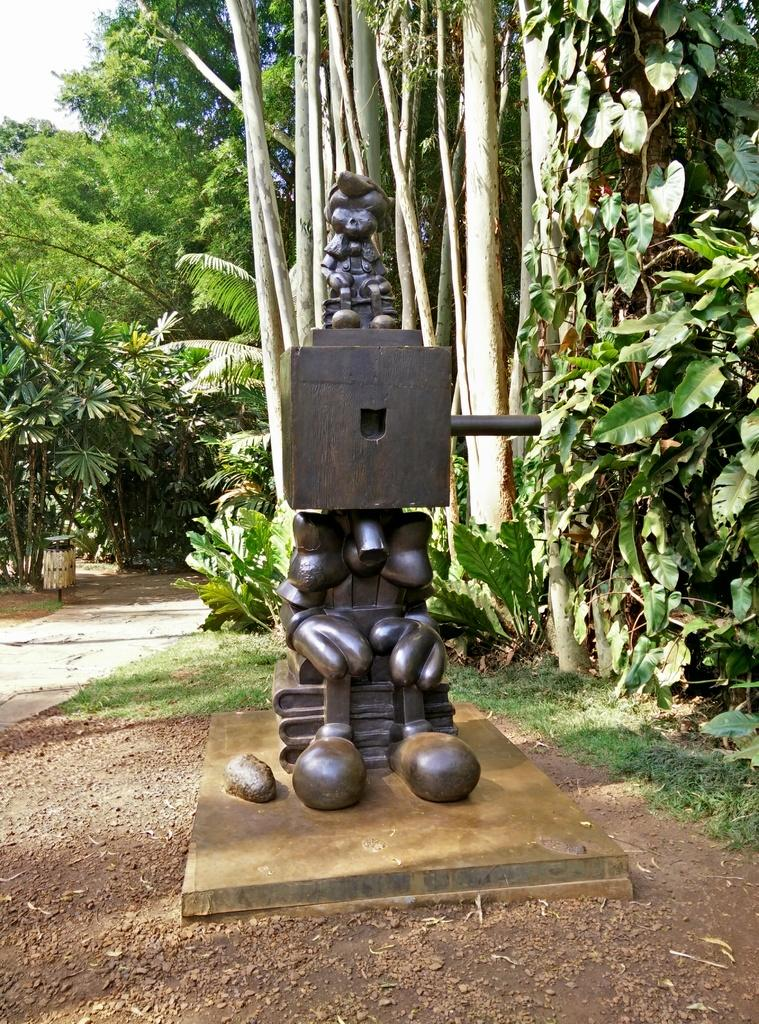What is the main subject in the center of the image? There is a sculpture in the center of the image. What can be seen in the background of the image? There are trees in the background of the image. What type of vegetation is at the bottom of the image? There is grass at the bottom of the image. Can you tell me how many keys are hanging from the sculpture in the image? There are no keys present in the image; the main subject is a sculpture without any keys. 